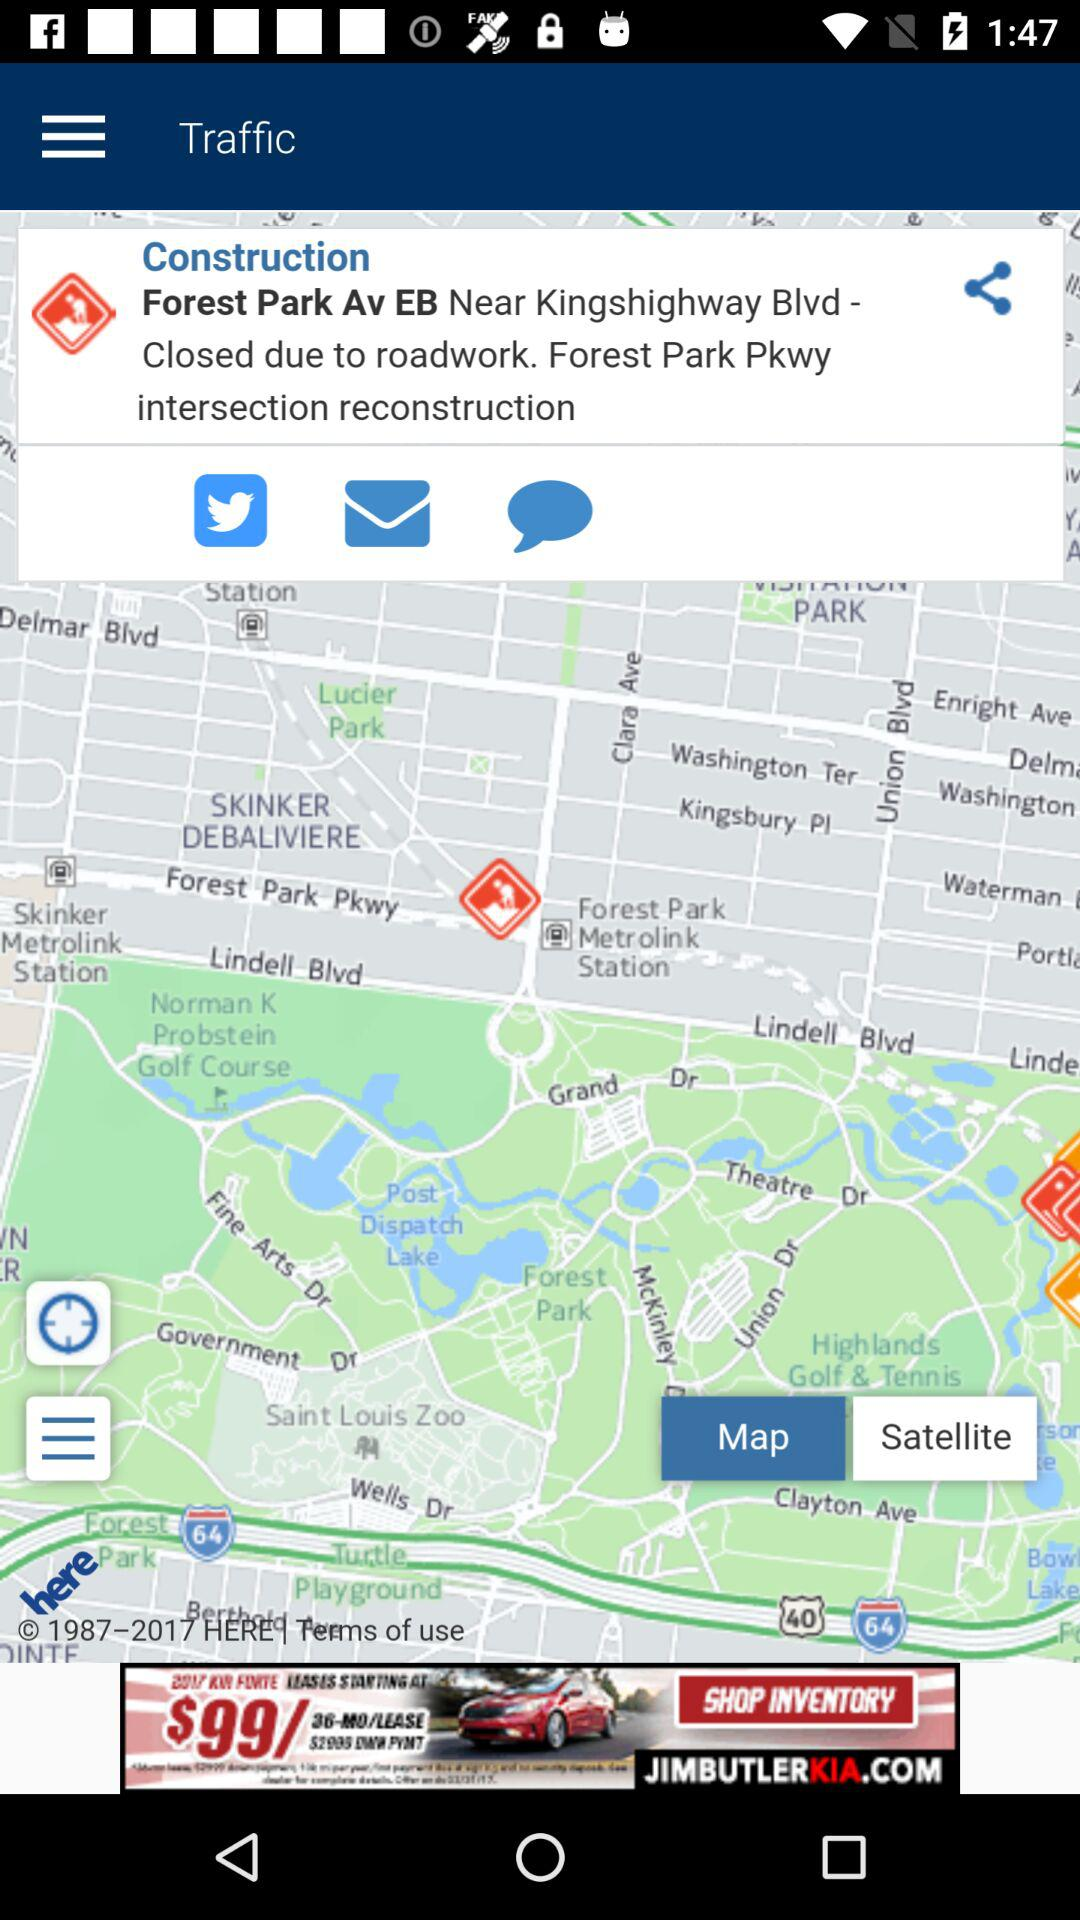Which location is closed due to roadwork? The location that is closed due to roadwork is Forest Park Av EB, Near Kingshighway Blvd. 